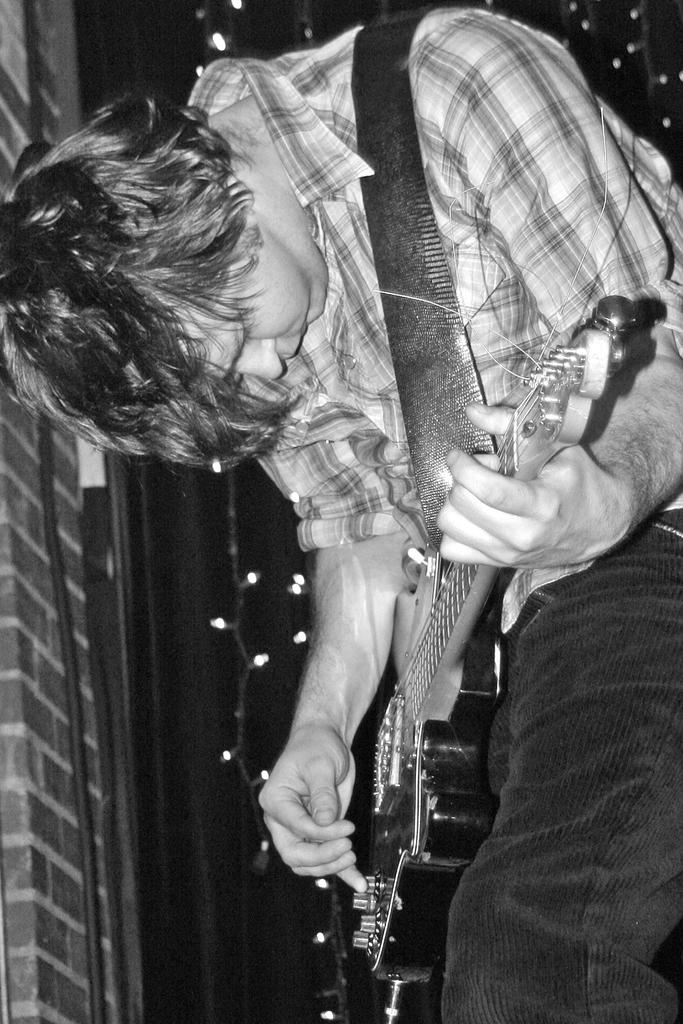What is the person in the center of the image doing? The person is playing a guitar. What can be seen in the background of the image? There is a wall, a wire, and string lights in the background of the image. What type of dolls are having a conversation about history in the image? There are no dolls present in the image, and no conversation about history is taking place. 